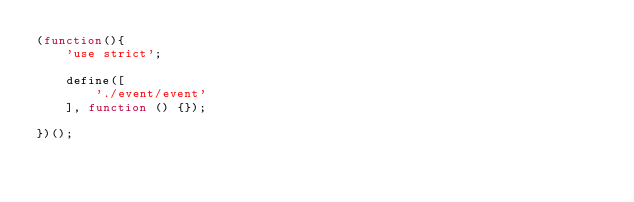Convert code to text. <code><loc_0><loc_0><loc_500><loc_500><_JavaScript_>(function(){
    'use strict';

    define([
        './event/event'
    ], function () {});

})();
</code> 